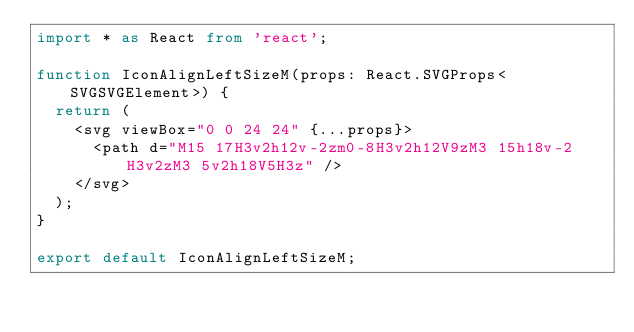<code> <loc_0><loc_0><loc_500><loc_500><_TypeScript_>import * as React from 'react';

function IconAlignLeftSizeM(props: React.SVGProps<SVGSVGElement>) {
  return (
    <svg viewBox="0 0 24 24" {...props}>
      <path d="M15 17H3v2h12v-2zm0-8H3v2h12V9zM3 15h18v-2H3v2zM3 5v2h18V5H3z" />
    </svg>
  );
}

export default IconAlignLeftSizeM;
</code> 